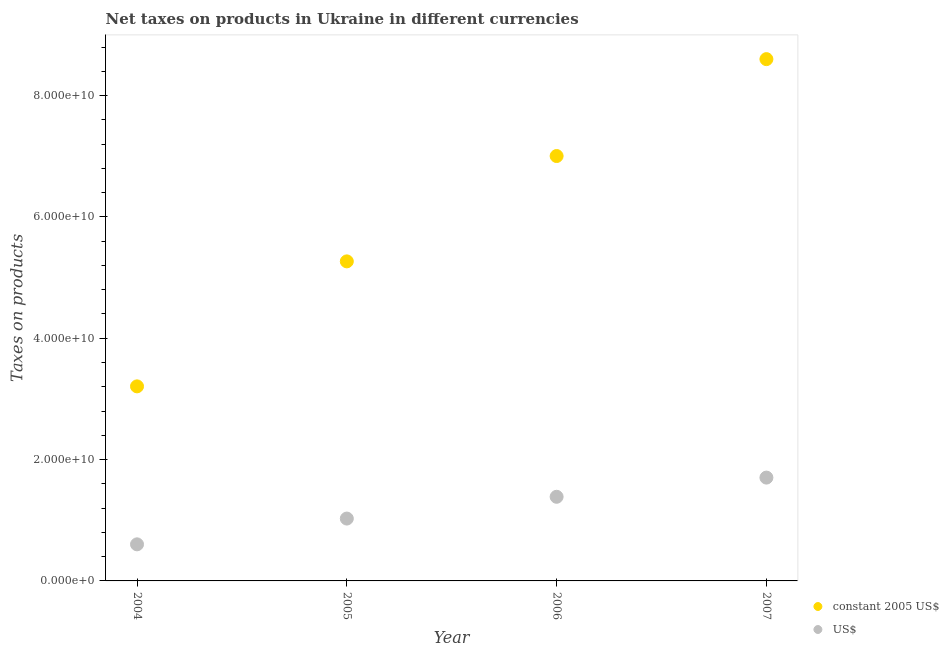How many different coloured dotlines are there?
Your response must be concise. 2. What is the net taxes in us$ in 2007?
Your response must be concise. 1.70e+1. Across all years, what is the maximum net taxes in constant 2005 us$?
Your response must be concise. 8.60e+1. Across all years, what is the minimum net taxes in us$?
Keep it short and to the point. 6.03e+09. What is the total net taxes in constant 2005 us$ in the graph?
Your answer should be very brief. 2.41e+11. What is the difference between the net taxes in constant 2005 us$ in 2005 and that in 2007?
Offer a very short reply. -3.33e+1. What is the difference between the net taxes in constant 2005 us$ in 2007 and the net taxes in us$ in 2004?
Give a very brief answer. 8.00e+1. What is the average net taxes in us$ per year?
Keep it short and to the point. 1.18e+1. In the year 2004, what is the difference between the net taxes in us$ and net taxes in constant 2005 us$?
Provide a short and direct response. -2.60e+1. What is the ratio of the net taxes in us$ in 2004 to that in 2005?
Keep it short and to the point. 0.59. Is the net taxes in constant 2005 us$ in 2005 less than that in 2006?
Give a very brief answer. Yes. What is the difference between the highest and the second highest net taxes in constant 2005 us$?
Give a very brief answer. 1.60e+1. What is the difference between the highest and the lowest net taxes in constant 2005 us$?
Provide a succinct answer. 5.39e+1. In how many years, is the net taxes in constant 2005 us$ greater than the average net taxes in constant 2005 us$ taken over all years?
Offer a terse response. 2. Does the net taxes in us$ monotonically increase over the years?
Provide a succinct answer. Yes. Is the net taxes in constant 2005 us$ strictly greater than the net taxes in us$ over the years?
Provide a succinct answer. Yes. How many dotlines are there?
Offer a very short reply. 2. How many years are there in the graph?
Give a very brief answer. 4. What is the difference between two consecutive major ticks on the Y-axis?
Make the answer very short. 2.00e+1. Does the graph contain any zero values?
Offer a terse response. No. Does the graph contain grids?
Your answer should be compact. No. What is the title of the graph?
Give a very brief answer. Net taxes on products in Ukraine in different currencies. What is the label or title of the X-axis?
Offer a very short reply. Year. What is the label or title of the Y-axis?
Provide a short and direct response. Taxes on products. What is the Taxes on products in constant 2005 US$ in 2004?
Your answer should be compact. 3.21e+1. What is the Taxes on products of US$ in 2004?
Offer a very short reply. 6.03e+09. What is the Taxes on products in constant 2005 US$ in 2005?
Ensure brevity in your answer.  5.27e+1. What is the Taxes on products in US$ in 2005?
Offer a terse response. 1.03e+1. What is the Taxes on products of constant 2005 US$ in 2006?
Ensure brevity in your answer.  7.00e+1. What is the Taxes on products in US$ in 2006?
Provide a short and direct response. 1.39e+1. What is the Taxes on products in constant 2005 US$ in 2007?
Your response must be concise. 8.60e+1. What is the Taxes on products in US$ in 2007?
Keep it short and to the point. 1.70e+1. Across all years, what is the maximum Taxes on products of constant 2005 US$?
Provide a succinct answer. 8.60e+1. Across all years, what is the maximum Taxes on products in US$?
Your answer should be compact. 1.70e+1. Across all years, what is the minimum Taxes on products of constant 2005 US$?
Ensure brevity in your answer.  3.21e+1. Across all years, what is the minimum Taxes on products of US$?
Keep it short and to the point. 6.03e+09. What is the total Taxes on products in constant 2005 US$ in the graph?
Your response must be concise. 2.41e+11. What is the total Taxes on products in US$ in the graph?
Provide a succinct answer. 4.72e+1. What is the difference between the Taxes on products of constant 2005 US$ in 2004 and that in 2005?
Provide a succinct answer. -2.06e+1. What is the difference between the Taxes on products in US$ in 2004 and that in 2005?
Give a very brief answer. -4.25e+09. What is the difference between the Taxes on products in constant 2005 US$ in 2004 and that in 2006?
Ensure brevity in your answer.  -3.80e+1. What is the difference between the Taxes on products in US$ in 2004 and that in 2006?
Offer a very short reply. -7.84e+09. What is the difference between the Taxes on products of constant 2005 US$ in 2004 and that in 2007?
Offer a terse response. -5.39e+1. What is the difference between the Taxes on products of US$ in 2004 and that in 2007?
Ensure brevity in your answer.  -1.10e+1. What is the difference between the Taxes on products in constant 2005 US$ in 2005 and that in 2006?
Make the answer very short. -1.74e+1. What is the difference between the Taxes on products of US$ in 2005 and that in 2006?
Your answer should be very brief. -3.59e+09. What is the difference between the Taxes on products of constant 2005 US$ in 2005 and that in 2007?
Give a very brief answer. -3.33e+1. What is the difference between the Taxes on products of US$ in 2005 and that in 2007?
Provide a short and direct response. -6.75e+09. What is the difference between the Taxes on products in constant 2005 US$ in 2006 and that in 2007?
Your response must be concise. -1.60e+1. What is the difference between the Taxes on products in US$ in 2006 and that in 2007?
Provide a succinct answer. -3.16e+09. What is the difference between the Taxes on products in constant 2005 US$ in 2004 and the Taxes on products in US$ in 2005?
Provide a succinct answer. 2.18e+1. What is the difference between the Taxes on products in constant 2005 US$ in 2004 and the Taxes on products in US$ in 2006?
Ensure brevity in your answer.  1.82e+1. What is the difference between the Taxes on products in constant 2005 US$ in 2004 and the Taxes on products in US$ in 2007?
Your answer should be compact. 1.50e+1. What is the difference between the Taxes on products of constant 2005 US$ in 2005 and the Taxes on products of US$ in 2006?
Provide a short and direct response. 3.88e+1. What is the difference between the Taxes on products in constant 2005 US$ in 2005 and the Taxes on products in US$ in 2007?
Offer a very short reply. 3.56e+1. What is the difference between the Taxes on products in constant 2005 US$ in 2006 and the Taxes on products in US$ in 2007?
Make the answer very short. 5.30e+1. What is the average Taxes on products of constant 2005 US$ per year?
Give a very brief answer. 6.02e+1. What is the average Taxes on products in US$ per year?
Offer a terse response. 1.18e+1. In the year 2004, what is the difference between the Taxes on products in constant 2005 US$ and Taxes on products in US$?
Provide a succinct answer. 2.60e+1. In the year 2005, what is the difference between the Taxes on products in constant 2005 US$ and Taxes on products in US$?
Offer a very short reply. 4.24e+1. In the year 2006, what is the difference between the Taxes on products of constant 2005 US$ and Taxes on products of US$?
Give a very brief answer. 5.62e+1. In the year 2007, what is the difference between the Taxes on products in constant 2005 US$ and Taxes on products in US$?
Your response must be concise. 6.90e+1. What is the ratio of the Taxes on products of constant 2005 US$ in 2004 to that in 2005?
Provide a short and direct response. 0.61. What is the ratio of the Taxes on products in US$ in 2004 to that in 2005?
Keep it short and to the point. 0.59. What is the ratio of the Taxes on products in constant 2005 US$ in 2004 to that in 2006?
Keep it short and to the point. 0.46. What is the ratio of the Taxes on products of US$ in 2004 to that in 2006?
Your answer should be compact. 0.43. What is the ratio of the Taxes on products of constant 2005 US$ in 2004 to that in 2007?
Make the answer very short. 0.37. What is the ratio of the Taxes on products of US$ in 2004 to that in 2007?
Your answer should be very brief. 0.35. What is the ratio of the Taxes on products in constant 2005 US$ in 2005 to that in 2006?
Your answer should be very brief. 0.75. What is the ratio of the Taxes on products of US$ in 2005 to that in 2006?
Offer a terse response. 0.74. What is the ratio of the Taxes on products in constant 2005 US$ in 2005 to that in 2007?
Provide a succinct answer. 0.61. What is the ratio of the Taxes on products in US$ in 2005 to that in 2007?
Keep it short and to the point. 0.6. What is the ratio of the Taxes on products of constant 2005 US$ in 2006 to that in 2007?
Your answer should be compact. 0.81. What is the ratio of the Taxes on products of US$ in 2006 to that in 2007?
Keep it short and to the point. 0.81. What is the difference between the highest and the second highest Taxes on products in constant 2005 US$?
Provide a succinct answer. 1.60e+1. What is the difference between the highest and the second highest Taxes on products in US$?
Make the answer very short. 3.16e+09. What is the difference between the highest and the lowest Taxes on products in constant 2005 US$?
Offer a terse response. 5.39e+1. What is the difference between the highest and the lowest Taxes on products in US$?
Give a very brief answer. 1.10e+1. 